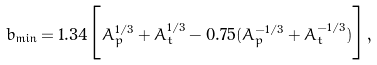<formula> <loc_0><loc_0><loc_500><loc_500>b _ { \min } = 1 . 3 4 \Big { [ } A _ { p } ^ { 1 / 3 } + A _ { t } ^ { 1 / 3 } - 0 . 7 5 ( A _ { p } ^ { - 1 / 3 } + A _ { t } ^ { - 1 / 3 } ) \Big { ] } ,</formula> 